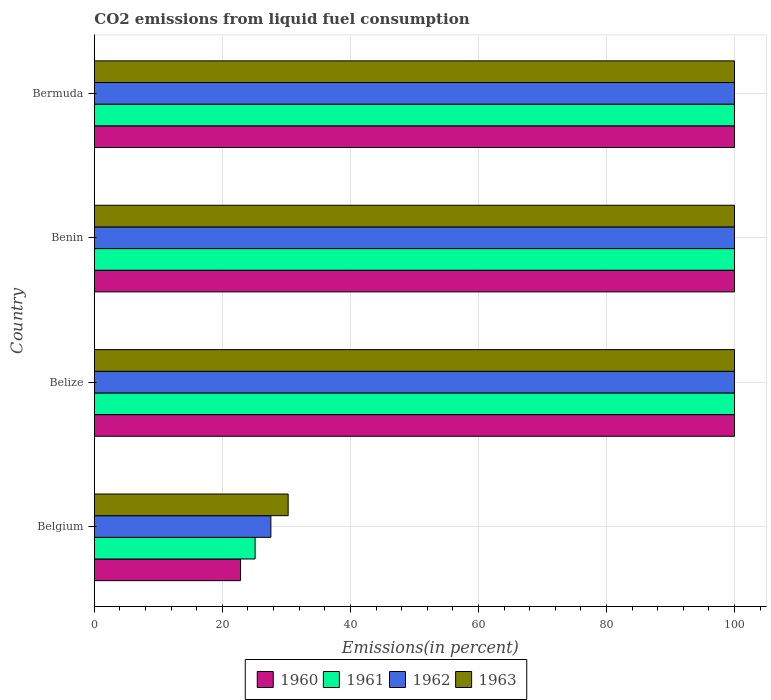How many groups of bars are there?
Offer a terse response. 4. Are the number of bars per tick equal to the number of legend labels?
Make the answer very short. Yes. In how many cases, is the number of bars for a given country not equal to the number of legend labels?
Give a very brief answer. 0. What is the total CO2 emitted in 1961 in Bermuda?
Make the answer very short. 100. Across all countries, what is the minimum total CO2 emitted in 1961?
Give a very brief answer. 25.12. In which country was the total CO2 emitted in 1961 maximum?
Make the answer very short. Belize. In which country was the total CO2 emitted in 1961 minimum?
Offer a terse response. Belgium. What is the total total CO2 emitted in 1961 in the graph?
Provide a succinct answer. 325.12. What is the difference between the total CO2 emitted in 1960 in Belize and that in Benin?
Provide a short and direct response. 0. What is the difference between the total CO2 emitted in 1961 in Bermuda and the total CO2 emitted in 1963 in Belize?
Your answer should be compact. 0. What is the average total CO2 emitted in 1961 per country?
Offer a terse response. 81.28. What is the difference between the total CO2 emitted in 1963 and total CO2 emitted in 1961 in Belize?
Give a very brief answer. 0. What is the ratio of the total CO2 emitted in 1960 in Belgium to that in Bermuda?
Keep it short and to the point. 0.23. Is the total CO2 emitted in 1963 in Belgium less than that in Belize?
Provide a short and direct response. Yes. What is the difference between the highest and the lowest total CO2 emitted in 1963?
Give a very brief answer. 69.72. What does the 1st bar from the bottom in Belgium represents?
Provide a succinct answer. 1960. Does the graph contain any zero values?
Provide a succinct answer. No. Where does the legend appear in the graph?
Offer a terse response. Bottom center. How many legend labels are there?
Ensure brevity in your answer.  4. How are the legend labels stacked?
Ensure brevity in your answer.  Horizontal. What is the title of the graph?
Keep it short and to the point. CO2 emissions from liquid fuel consumption. What is the label or title of the X-axis?
Your response must be concise. Emissions(in percent). What is the label or title of the Y-axis?
Your answer should be very brief. Country. What is the Emissions(in percent) of 1960 in Belgium?
Your response must be concise. 22.84. What is the Emissions(in percent) in 1961 in Belgium?
Offer a very short reply. 25.12. What is the Emissions(in percent) in 1962 in Belgium?
Offer a terse response. 27.58. What is the Emissions(in percent) in 1963 in Belgium?
Your answer should be compact. 30.28. What is the Emissions(in percent) in 1962 in Belize?
Give a very brief answer. 100. What is the Emissions(in percent) in 1963 in Belize?
Give a very brief answer. 100. What is the Emissions(in percent) in 1960 in Benin?
Keep it short and to the point. 100. What is the Emissions(in percent) of 1962 in Benin?
Your response must be concise. 100. What is the Emissions(in percent) of 1960 in Bermuda?
Your response must be concise. 100. Across all countries, what is the maximum Emissions(in percent) of 1960?
Your response must be concise. 100. Across all countries, what is the maximum Emissions(in percent) of 1963?
Offer a terse response. 100. Across all countries, what is the minimum Emissions(in percent) in 1960?
Keep it short and to the point. 22.84. Across all countries, what is the minimum Emissions(in percent) in 1961?
Keep it short and to the point. 25.12. Across all countries, what is the minimum Emissions(in percent) in 1962?
Give a very brief answer. 27.58. Across all countries, what is the minimum Emissions(in percent) in 1963?
Offer a very short reply. 30.28. What is the total Emissions(in percent) in 1960 in the graph?
Offer a terse response. 322.84. What is the total Emissions(in percent) of 1961 in the graph?
Offer a terse response. 325.12. What is the total Emissions(in percent) in 1962 in the graph?
Offer a terse response. 327.58. What is the total Emissions(in percent) in 1963 in the graph?
Keep it short and to the point. 330.28. What is the difference between the Emissions(in percent) of 1960 in Belgium and that in Belize?
Your response must be concise. -77.16. What is the difference between the Emissions(in percent) of 1961 in Belgium and that in Belize?
Your answer should be compact. -74.88. What is the difference between the Emissions(in percent) of 1962 in Belgium and that in Belize?
Keep it short and to the point. -72.42. What is the difference between the Emissions(in percent) of 1963 in Belgium and that in Belize?
Your response must be concise. -69.72. What is the difference between the Emissions(in percent) of 1960 in Belgium and that in Benin?
Your answer should be very brief. -77.16. What is the difference between the Emissions(in percent) in 1961 in Belgium and that in Benin?
Make the answer very short. -74.88. What is the difference between the Emissions(in percent) of 1962 in Belgium and that in Benin?
Your response must be concise. -72.42. What is the difference between the Emissions(in percent) in 1963 in Belgium and that in Benin?
Ensure brevity in your answer.  -69.72. What is the difference between the Emissions(in percent) of 1960 in Belgium and that in Bermuda?
Your answer should be compact. -77.16. What is the difference between the Emissions(in percent) of 1961 in Belgium and that in Bermuda?
Ensure brevity in your answer.  -74.88. What is the difference between the Emissions(in percent) of 1962 in Belgium and that in Bermuda?
Provide a succinct answer. -72.42. What is the difference between the Emissions(in percent) in 1963 in Belgium and that in Bermuda?
Keep it short and to the point. -69.72. What is the difference between the Emissions(in percent) in 1960 in Belize and that in Benin?
Provide a short and direct response. 0. What is the difference between the Emissions(in percent) in 1962 in Belize and that in Benin?
Provide a short and direct response. 0. What is the difference between the Emissions(in percent) of 1960 in Belize and that in Bermuda?
Your response must be concise. 0. What is the difference between the Emissions(in percent) of 1960 in Belgium and the Emissions(in percent) of 1961 in Belize?
Offer a terse response. -77.16. What is the difference between the Emissions(in percent) in 1960 in Belgium and the Emissions(in percent) in 1962 in Belize?
Your response must be concise. -77.16. What is the difference between the Emissions(in percent) in 1960 in Belgium and the Emissions(in percent) in 1963 in Belize?
Your response must be concise. -77.16. What is the difference between the Emissions(in percent) of 1961 in Belgium and the Emissions(in percent) of 1962 in Belize?
Provide a short and direct response. -74.88. What is the difference between the Emissions(in percent) in 1961 in Belgium and the Emissions(in percent) in 1963 in Belize?
Provide a short and direct response. -74.88. What is the difference between the Emissions(in percent) of 1962 in Belgium and the Emissions(in percent) of 1963 in Belize?
Offer a terse response. -72.42. What is the difference between the Emissions(in percent) in 1960 in Belgium and the Emissions(in percent) in 1961 in Benin?
Your answer should be compact. -77.16. What is the difference between the Emissions(in percent) in 1960 in Belgium and the Emissions(in percent) in 1962 in Benin?
Give a very brief answer. -77.16. What is the difference between the Emissions(in percent) of 1960 in Belgium and the Emissions(in percent) of 1963 in Benin?
Provide a succinct answer. -77.16. What is the difference between the Emissions(in percent) in 1961 in Belgium and the Emissions(in percent) in 1962 in Benin?
Provide a succinct answer. -74.88. What is the difference between the Emissions(in percent) in 1961 in Belgium and the Emissions(in percent) in 1963 in Benin?
Ensure brevity in your answer.  -74.88. What is the difference between the Emissions(in percent) of 1962 in Belgium and the Emissions(in percent) of 1963 in Benin?
Your response must be concise. -72.42. What is the difference between the Emissions(in percent) of 1960 in Belgium and the Emissions(in percent) of 1961 in Bermuda?
Your answer should be compact. -77.16. What is the difference between the Emissions(in percent) in 1960 in Belgium and the Emissions(in percent) in 1962 in Bermuda?
Your answer should be very brief. -77.16. What is the difference between the Emissions(in percent) in 1960 in Belgium and the Emissions(in percent) in 1963 in Bermuda?
Keep it short and to the point. -77.16. What is the difference between the Emissions(in percent) of 1961 in Belgium and the Emissions(in percent) of 1962 in Bermuda?
Provide a succinct answer. -74.88. What is the difference between the Emissions(in percent) in 1961 in Belgium and the Emissions(in percent) in 1963 in Bermuda?
Offer a very short reply. -74.88. What is the difference between the Emissions(in percent) of 1962 in Belgium and the Emissions(in percent) of 1963 in Bermuda?
Keep it short and to the point. -72.42. What is the difference between the Emissions(in percent) of 1960 in Belize and the Emissions(in percent) of 1961 in Benin?
Keep it short and to the point. 0. What is the difference between the Emissions(in percent) in 1960 in Belize and the Emissions(in percent) in 1962 in Benin?
Keep it short and to the point. 0. What is the difference between the Emissions(in percent) of 1960 in Belize and the Emissions(in percent) of 1963 in Benin?
Keep it short and to the point. 0. What is the difference between the Emissions(in percent) of 1960 in Belize and the Emissions(in percent) of 1961 in Bermuda?
Ensure brevity in your answer.  0. What is the difference between the Emissions(in percent) of 1960 in Belize and the Emissions(in percent) of 1962 in Bermuda?
Keep it short and to the point. 0. What is the difference between the Emissions(in percent) of 1961 in Belize and the Emissions(in percent) of 1962 in Bermuda?
Provide a short and direct response. 0. What is the average Emissions(in percent) in 1960 per country?
Your response must be concise. 80.71. What is the average Emissions(in percent) of 1961 per country?
Your answer should be very brief. 81.28. What is the average Emissions(in percent) in 1962 per country?
Your response must be concise. 81.89. What is the average Emissions(in percent) of 1963 per country?
Provide a short and direct response. 82.57. What is the difference between the Emissions(in percent) in 1960 and Emissions(in percent) in 1961 in Belgium?
Your answer should be compact. -2.28. What is the difference between the Emissions(in percent) in 1960 and Emissions(in percent) in 1962 in Belgium?
Offer a very short reply. -4.74. What is the difference between the Emissions(in percent) in 1960 and Emissions(in percent) in 1963 in Belgium?
Offer a terse response. -7.44. What is the difference between the Emissions(in percent) of 1961 and Emissions(in percent) of 1962 in Belgium?
Keep it short and to the point. -2.46. What is the difference between the Emissions(in percent) in 1961 and Emissions(in percent) in 1963 in Belgium?
Make the answer very short. -5.16. What is the difference between the Emissions(in percent) in 1962 and Emissions(in percent) in 1963 in Belgium?
Give a very brief answer. -2.7. What is the difference between the Emissions(in percent) in 1961 and Emissions(in percent) in 1962 in Belize?
Your response must be concise. 0. What is the difference between the Emissions(in percent) of 1960 and Emissions(in percent) of 1961 in Benin?
Your response must be concise. 0. What is the difference between the Emissions(in percent) in 1960 and Emissions(in percent) in 1962 in Benin?
Provide a short and direct response. 0. What is the difference between the Emissions(in percent) in 1960 and Emissions(in percent) in 1963 in Benin?
Provide a succinct answer. 0. What is the difference between the Emissions(in percent) in 1961 and Emissions(in percent) in 1962 in Benin?
Make the answer very short. 0. What is the difference between the Emissions(in percent) of 1961 and Emissions(in percent) of 1963 in Benin?
Provide a short and direct response. 0. What is the difference between the Emissions(in percent) of 1960 and Emissions(in percent) of 1961 in Bermuda?
Your response must be concise. 0. What is the difference between the Emissions(in percent) of 1960 and Emissions(in percent) of 1962 in Bermuda?
Keep it short and to the point. 0. What is the difference between the Emissions(in percent) in 1960 and Emissions(in percent) in 1963 in Bermuda?
Your response must be concise. 0. What is the difference between the Emissions(in percent) of 1961 and Emissions(in percent) of 1963 in Bermuda?
Make the answer very short. 0. What is the ratio of the Emissions(in percent) of 1960 in Belgium to that in Belize?
Your response must be concise. 0.23. What is the ratio of the Emissions(in percent) of 1961 in Belgium to that in Belize?
Make the answer very short. 0.25. What is the ratio of the Emissions(in percent) in 1962 in Belgium to that in Belize?
Keep it short and to the point. 0.28. What is the ratio of the Emissions(in percent) in 1963 in Belgium to that in Belize?
Provide a succinct answer. 0.3. What is the ratio of the Emissions(in percent) in 1960 in Belgium to that in Benin?
Offer a very short reply. 0.23. What is the ratio of the Emissions(in percent) in 1961 in Belgium to that in Benin?
Ensure brevity in your answer.  0.25. What is the ratio of the Emissions(in percent) of 1962 in Belgium to that in Benin?
Give a very brief answer. 0.28. What is the ratio of the Emissions(in percent) in 1963 in Belgium to that in Benin?
Provide a short and direct response. 0.3. What is the ratio of the Emissions(in percent) in 1960 in Belgium to that in Bermuda?
Offer a terse response. 0.23. What is the ratio of the Emissions(in percent) in 1961 in Belgium to that in Bermuda?
Give a very brief answer. 0.25. What is the ratio of the Emissions(in percent) of 1962 in Belgium to that in Bermuda?
Provide a short and direct response. 0.28. What is the ratio of the Emissions(in percent) of 1963 in Belgium to that in Bermuda?
Make the answer very short. 0.3. What is the ratio of the Emissions(in percent) in 1962 in Belize to that in Benin?
Give a very brief answer. 1. What is the ratio of the Emissions(in percent) of 1962 in Belize to that in Bermuda?
Give a very brief answer. 1. What is the ratio of the Emissions(in percent) in 1963 in Belize to that in Bermuda?
Offer a very short reply. 1. What is the ratio of the Emissions(in percent) of 1960 in Benin to that in Bermuda?
Make the answer very short. 1. What is the ratio of the Emissions(in percent) in 1962 in Benin to that in Bermuda?
Your answer should be compact. 1. What is the difference between the highest and the second highest Emissions(in percent) of 1962?
Make the answer very short. 0. What is the difference between the highest and the second highest Emissions(in percent) of 1963?
Offer a terse response. 0. What is the difference between the highest and the lowest Emissions(in percent) in 1960?
Keep it short and to the point. 77.16. What is the difference between the highest and the lowest Emissions(in percent) of 1961?
Your answer should be compact. 74.88. What is the difference between the highest and the lowest Emissions(in percent) in 1962?
Ensure brevity in your answer.  72.42. What is the difference between the highest and the lowest Emissions(in percent) in 1963?
Ensure brevity in your answer.  69.72. 